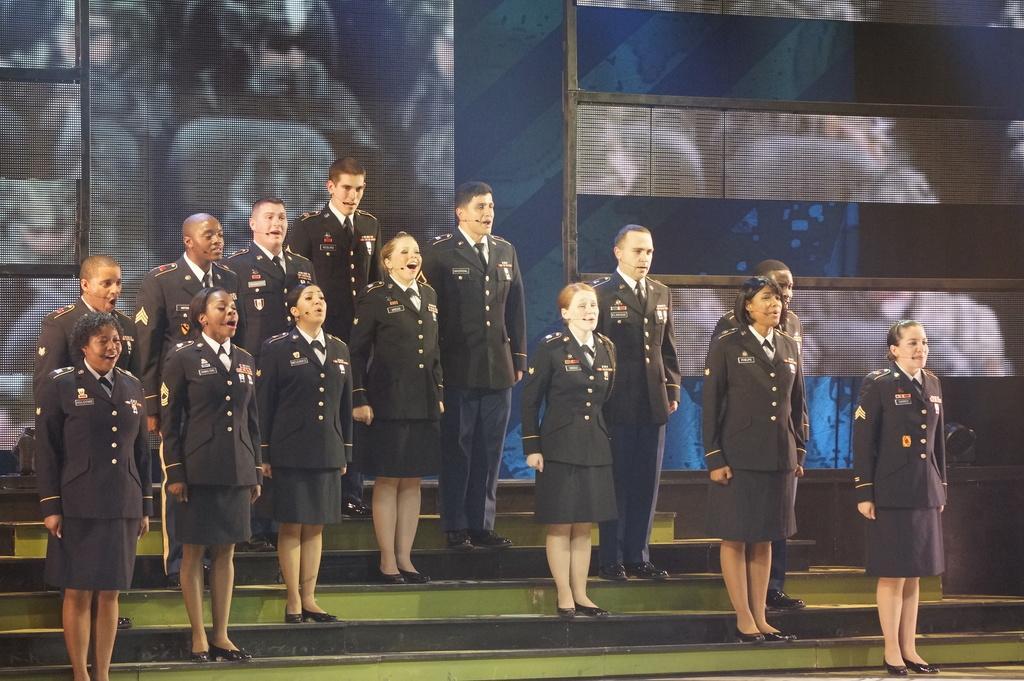Describe this image in one or two sentences. In this image I can see a group of people are standing on the staircase. In the background I can see a wall and screen. This image is taken may be during a day. 